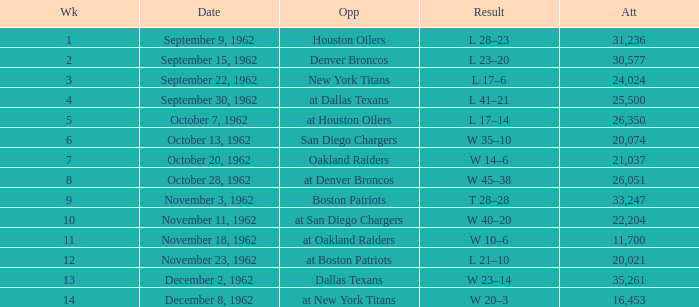What week was the attendance smaller than 22,204 on December 8, 1962? 14.0. 